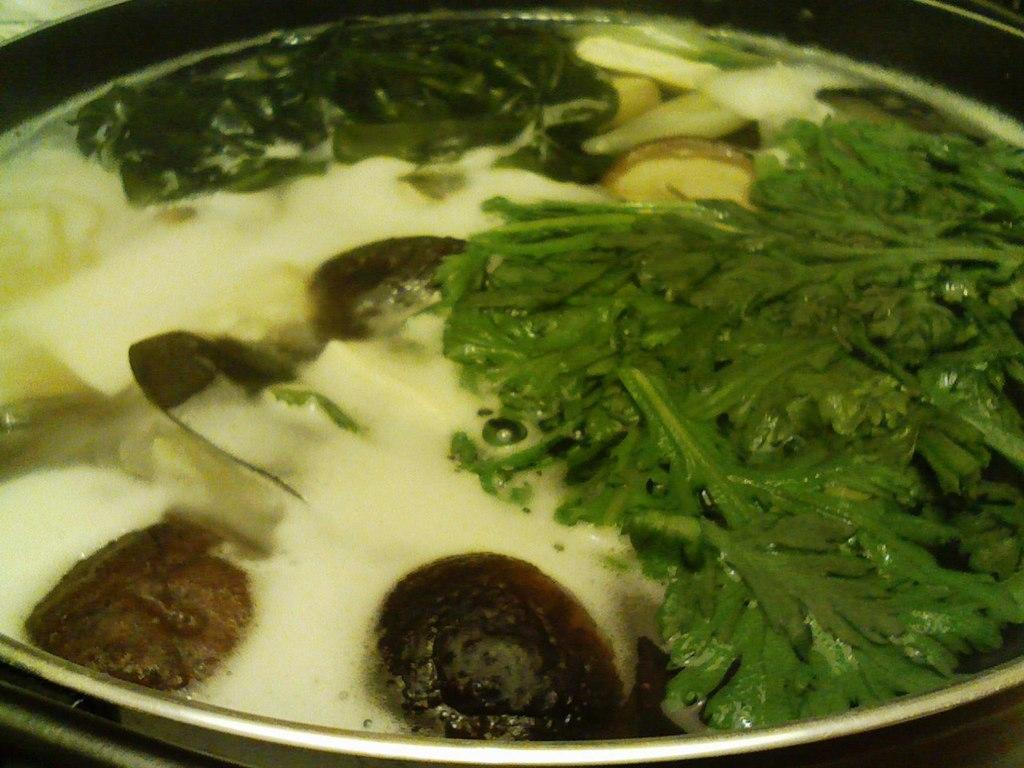What type of plant material is present in the image? There are vegetable leaves in the image. What else can be seen in the image besides the vegetable leaves? There is food in a container in the image. What type of pancake is being served in the image? There is no pancake present in the image; it only features vegetable leaves and food in a container. 